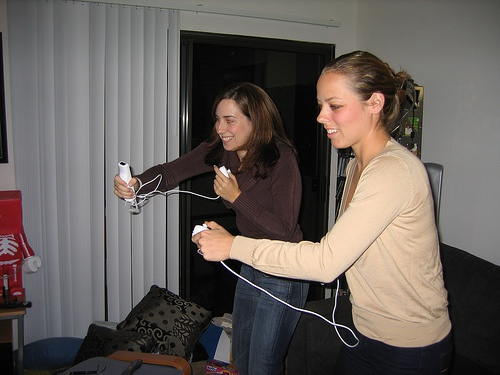Describe the objects in this image and their specific colors. I can see people in gray, tan, and black tones, people in gray and black tones, couch in gray, black, maroon, and darkgreen tones, couch in gray, black, white, and darkgray tones, and remote in gray, lightgray, darkgray, and black tones in this image. 